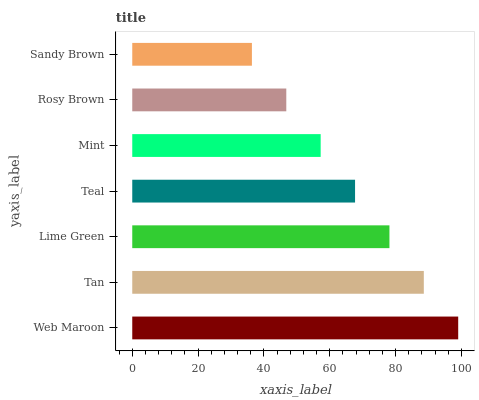Is Sandy Brown the minimum?
Answer yes or no. Yes. Is Web Maroon the maximum?
Answer yes or no. Yes. Is Tan the minimum?
Answer yes or no. No. Is Tan the maximum?
Answer yes or no. No. Is Web Maroon greater than Tan?
Answer yes or no. Yes. Is Tan less than Web Maroon?
Answer yes or no. Yes. Is Tan greater than Web Maroon?
Answer yes or no. No. Is Web Maroon less than Tan?
Answer yes or no. No. Is Teal the high median?
Answer yes or no. Yes. Is Teal the low median?
Answer yes or no. Yes. Is Sandy Brown the high median?
Answer yes or no. No. Is Lime Green the low median?
Answer yes or no. No. 